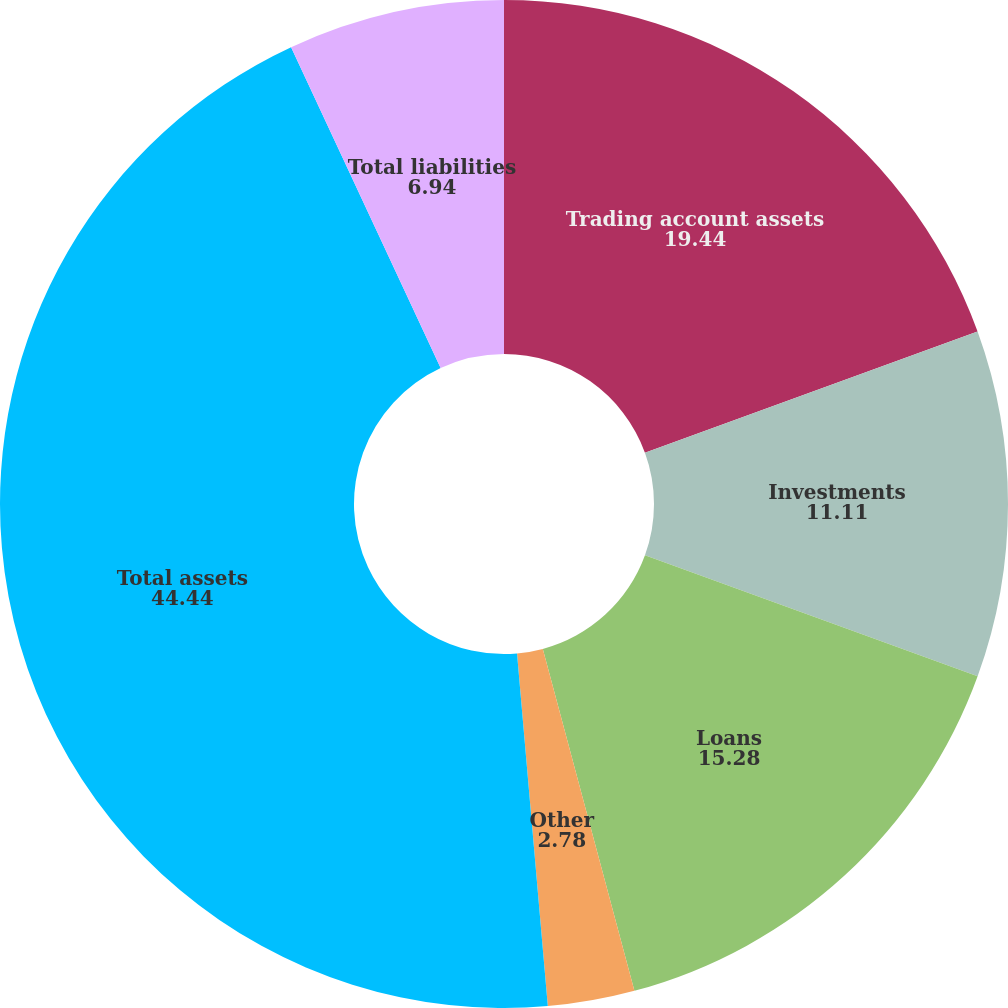Convert chart. <chart><loc_0><loc_0><loc_500><loc_500><pie_chart><fcel>Trading account assets<fcel>Investments<fcel>Loans<fcel>Other<fcel>Total assets<fcel>Total liabilities<nl><fcel>19.44%<fcel>11.11%<fcel>15.28%<fcel>2.78%<fcel>44.44%<fcel>6.94%<nl></chart> 